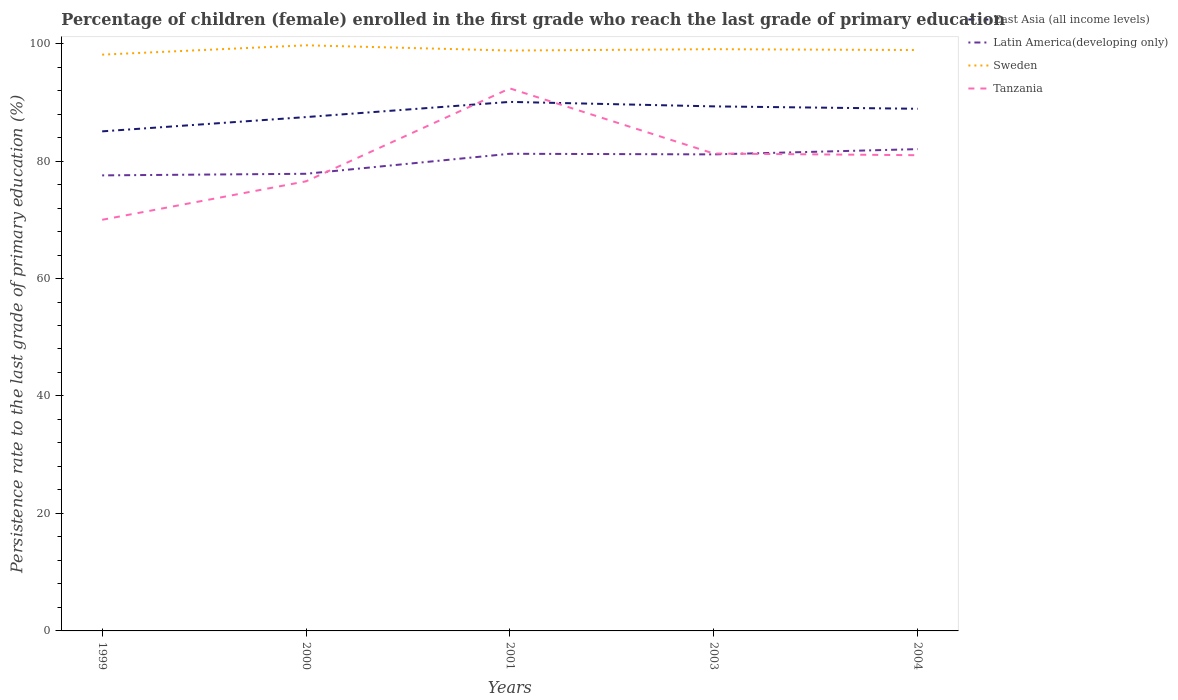How many different coloured lines are there?
Keep it short and to the point. 4. Does the line corresponding to Latin America(developing only) intersect with the line corresponding to East Asia (all income levels)?
Keep it short and to the point. No. Is the number of lines equal to the number of legend labels?
Your answer should be compact. Yes. Across all years, what is the maximum persistence rate of children in Tanzania?
Ensure brevity in your answer.  70. What is the total persistence rate of children in Sweden in the graph?
Your answer should be very brief. -0.23. What is the difference between the highest and the second highest persistence rate of children in East Asia (all income levels)?
Your answer should be compact. 5.02. What is the difference between the highest and the lowest persistence rate of children in East Asia (all income levels)?
Make the answer very short. 3. Does the graph contain any zero values?
Ensure brevity in your answer.  No. How many legend labels are there?
Give a very brief answer. 4. What is the title of the graph?
Your answer should be very brief. Percentage of children (female) enrolled in the first grade who reach the last grade of primary education. What is the label or title of the Y-axis?
Provide a short and direct response. Persistence rate to the last grade of primary education (%). What is the Persistence rate to the last grade of primary education (%) in East Asia (all income levels) in 1999?
Ensure brevity in your answer.  85.05. What is the Persistence rate to the last grade of primary education (%) in Latin America(developing only) in 1999?
Offer a very short reply. 77.56. What is the Persistence rate to the last grade of primary education (%) of Sweden in 1999?
Your answer should be compact. 98.12. What is the Persistence rate to the last grade of primary education (%) of Tanzania in 1999?
Provide a short and direct response. 70. What is the Persistence rate to the last grade of primary education (%) of East Asia (all income levels) in 2000?
Offer a very short reply. 87.48. What is the Persistence rate to the last grade of primary education (%) of Latin America(developing only) in 2000?
Provide a short and direct response. 77.83. What is the Persistence rate to the last grade of primary education (%) of Sweden in 2000?
Give a very brief answer. 99.7. What is the Persistence rate to the last grade of primary education (%) in Tanzania in 2000?
Give a very brief answer. 76.55. What is the Persistence rate to the last grade of primary education (%) in East Asia (all income levels) in 2001?
Make the answer very short. 90.07. What is the Persistence rate to the last grade of primary education (%) in Latin America(developing only) in 2001?
Keep it short and to the point. 81.24. What is the Persistence rate to the last grade of primary education (%) in Sweden in 2001?
Ensure brevity in your answer.  98.81. What is the Persistence rate to the last grade of primary education (%) of Tanzania in 2001?
Your answer should be compact. 92.36. What is the Persistence rate to the last grade of primary education (%) in East Asia (all income levels) in 2003?
Offer a very short reply. 89.31. What is the Persistence rate to the last grade of primary education (%) in Latin America(developing only) in 2003?
Offer a very short reply. 81.13. What is the Persistence rate to the last grade of primary education (%) of Sweden in 2003?
Make the answer very short. 99.04. What is the Persistence rate to the last grade of primary education (%) in Tanzania in 2003?
Ensure brevity in your answer.  81.28. What is the Persistence rate to the last grade of primary education (%) in East Asia (all income levels) in 2004?
Make the answer very short. 88.9. What is the Persistence rate to the last grade of primary education (%) in Latin America(developing only) in 2004?
Offer a very short reply. 82.03. What is the Persistence rate to the last grade of primary education (%) of Sweden in 2004?
Provide a succinct answer. 98.9. What is the Persistence rate to the last grade of primary education (%) in Tanzania in 2004?
Make the answer very short. 80.99. Across all years, what is the maximum Persistence rate to the last grade of primary education (%) in East Asia (all income levels)?
Provide a short and direct response. 90.07. Across all years, what is the maximum Persistence rate to the last grade of primary education (%) in Latin America(developing only)?
Give a very brief answer. 82.03. Across all years, what is the maximum Persistence rate to the last grade of primary education (%) in Sweden?
Provide a succinct answer. 99.7. Across all years, what is the maximum Persistence rate to the last grade of primary education (%) in Tanzania?
Your answer should be compact. 92.36. Across all years, what is the minimum Persistence rate to the last grade of primary education (%) of East Asia (all income levels)?
Your answer should be compact. 85.05. Across all years, what is the minimum Persistence rate to the last grade of primary education (%) of Latin America(developing only)?
Offer a terse response. 77.56. Across all years, what is the minimum Persistence rate to the last grade of primary education (%) in Sweden?
Offer a terse response. 98.12. Across all years, what is the minimum Persistence rate to the last grade of primary education (%) in Tanzania?
Offer a very short reply. 70. What is the total Persistence rate to the last grade of primary education (%) in East Asia (all income levels) in the graph?
Give a very brief answer. 440.81. What is the total Persistence rate to the last grade of primary education (%) in Latin America(developing only) in the graph?
Give a very brief answer. 399.79. What is the total Persistence rate to the last grade of primary education (%) of Sweden in the graph?
Keep it short and to the point. 494.57. What is the total Persistence rate to the last grade of primary education (%) in Tanzania in the graph?
Offer a very short reply. 401.18. What is the difference between the Persistence rate to the last grade of primary education (%) of East Asia (all income levels) in 1999 and that in 2000?
Keep it short and to the point. -2.43. What is the difference between the Persistence rate to the last grade of primary education (%) in Latin America(developing only) in 1999 and that in 2000?
Your answer should be very brief. -0.27. What is the difference between the Persistence rate to the last grade of primary education (%) in Sweden in 1999 and that in 2000?
Your answer should be compact. -1.59. What is the difference between the Persistence rate to the last grade of primary education (%) of Tanzania in 1999 and that in 2000?
Your answer should be compact. -6.55. What is the difference between the Persistence rate to the last grade of primary education (%) in East Asia (all income levels) in 1999 and that in 2001?
Ensure brevity in your answer.  -5.02. What is the difference between the Persistence rate to the last grade of primary education (%) in Latin America(developing only) in 1999 and that in 2001?
Your answer should be compact. -3.68. What is the difference between the Persistence rate to the last grade of primary education (%) in Sweden in 1999 and that in 2001?
Your answer should be compact. -0.7. What is the difference between the Persistence rate to the last grade of primary education (%) of Tanzania in 1999 and that in 2001?
Ensure brevity in your answer.  -22.37. What is the difference between the Persistence rate to the last grade of primary education (%) of East Asia (all income levels) in 1999 and that in 2003?
Your answer should be very brief. -4.25. What is the difference between the Persistence rate to the last grade of primary education (%) of Latin America(developing only) in 1999 and that in 2003?
Offer a terse response. -3.57. What is the difference between the Persistence rate to the last grade of primary education (%) in Sweden in 1999 and that in 2003?
Keep it short and to the point. -0.93. What is the difference between the Persistence rate to the last grade of primary education (%) in Tanzania in 1999 and that in 2003?
Provide a succinct answer. -11.28. What is the difference between the Persistence rate to the last grade of primary education (%) of East Asia (all income levels) in 1999 and that in 2004?
Make the answer very short. -3.85. What is the difference between the Persistence rate to the last grade of primary education (%) of Latin America(developing only) in 1999 and that in 2004?
Your response must be concise. -4.47. What is the difference between the Persistence rate to the last grade of primary education (%) in Sweden in 1999 and that in 2004?
Provide a short and direct response. -0.78. What is the difference between the Persistence rate to the last grade of primary education (%) of Tanzania in 1999 and that in 2004?
Make the answer very short. -10.99. What is the difference between the Persistence rate to the last grade of primary education (%) of East Asia (all income levels) in 2000 and that in 2001?
Your answer should be compact. -2.59. What is the difference between the Persistence rate to the last grade of primary education (%) of Latin America(developing only) in 2000 and that in 2001?
Offer a very short reply. -3.41. What is the difference between the Persistence rate to the last grade of primary education (%) in Sweden in 2000 and that in 2001?
Your answer should be very brief. 0.89. What is the difference between the Persistence rate to the last grade of primary education (%) of Tanzania in 2000 and that in 2001?
Provide a succinct answer. -15.82. What is the difference between the Persistence rate to the last grade of primary education (%) in East Asia (all income levels) in 2000 and that in 2003?
Make the answer very short. -1.82. What is the difference between the Persistence rate to the last grade of primary education (%) in Latin America(developing only) in 2000 and that in 2003?
Offer a terse response. -3.3. What is the difference between the Persistence rate to the last grade of primary education (%) of Sweden in 2000 and that in 2003?
Keep it short and to the point. 0.66. What is the difference between the Persistence rate to the last grade of primary education (%) in Tanzania in 2000 and that in 2003?
Your answer should be compact. -4.73. What is the difference between the Persistence rate to the last grade of primary education (%) of East Asia (all income levels) in 2000 and that in 2004?
Your answer should be compact. -1.41. What is the difference between the Persistence rate to the last grade of primary education (%) of Latin America(developing only) in 2000 and that in 2004?
Keep it short and to the point. -4.2. What is the difference between the Persistence rate to the last grade of primary education (%) in Sweden in 2000 and that in 2004?
Provide a succinct answer. 0.81. What is the difference between the Persistence rate to the last grade of primary education (%) in Tanzania in 2000 and that in 2004?
Offer a terse response. -4.45. What is the difference between the Persistence rate to the last grade of primary education (%) in East Asia (all income levels) in 2001 and that in 2003?
Offer a very short reply. 0.76. What is the difference between the Persistence rate to the last grade of primary education (%) in Latin America(developing only) in 2001 and that in 2003?
Offer a very short reply. 0.1. What is the difference between the Persistence rate to the last grade of primary education (%) in Sweden in 2001 and that in 2003?
Make the answer very short. -0.23. What is the difference between the Persistence rate to the last grade of primary education (%) in Tanzania in 2001 and that in 2003?
Offer a very short reply. 11.09. What is the difference between the Persistence rate to the last grade of primary education (%) of East Asia (all income levels) in 2001 and that in 2004?
Offer a terse response. 1.17. What is the difference between the Persistence rate to the last grade of primary education (%) of Latin America(developing only) in 2001 and that in 2004?
Your answer should be very brief. -0.79. What is the difference between the Persistence rate to the last grade of primary education (%) in Sweden in 2001 and that in 2004?
Give a very brief answer. -0.09. What is the difference between the Persistence rate to the last grade of primary education (%) in Tanzania in 2001 and that in 2004?
Offer a terse response. 11.37. What is the difference between the Persistence rate to the last grade of primary education (%) of East Asia (all income levels) in 2003 and that in 2004?
Your answer should be compact. 0.41. What is the difference between the Persistence rate to the last grade of primary education (%) in Latin America(developing only) in 2003 and that in 2004?
Provide a succinct answer. -0.89. What is the difference between the Persistence rate to the last grade of primary education (%) in Sweden in 2003 and that in 2004?
Provide a short and direct response. 0.14. What is the difference between the Persistence rate to the last grade of primary education (%) of Tanzania in 2003 and that in 2004?
Offer a very short reply. 0.28. What is the difference between the Persistence rate to the last grade of primary education (%) of East Asia (all income levels) in 1999 and the Persistence rate to the last grade of primary education (%) of Latin America(developing only) in 2000?
Your response must be concise. 7.22. What is the difference between the Persistence rate to the last grade of primary education (%) in East Asia (all income levels) in 1999 and the Persistence rate to the last grade of primary education (%) in Sweden in 2000?
Offer a very short reply. -14.65. What is the difference between the Persistence rate to the last grade of primary education (%) in East Asia (all income levels) in 1999 and the Persistence rate to the last grade of primary education (%) in Tanzania in 2000?
Keep it short and to the point. 8.51. What is the difference between the Persistence rate to the last grade of primary education (%) in Latin America(developing only) in 1999 and the Persistence rate to the last grade of primary education (%) in Sweden in 2000?
Your answer should be compact. -22.15. What is the difference between the Persistence rate to the last grade of primary education (%) of Sweden in 1999 and the Persistence rate to the last grade of primary education (%) of Tanzania in 2000?
Provide a short and direct response. 21.57. What is the difference between the Persistence rate to the last grade of primary education (%) in East Asia (all income levels) in 1999 and the Persistence rate to the last grade of primary education (%) in Latin America(developing only) in 2001?
Your answer should be very brief. 3.82. What is the difference between the Persistence rate to the last grade of primary education (%) in East Asia (all income levels) in 1999 and the Persistence rate to the last grade of primary education (%) in Sweden in 2001?
Keep it short and to the point. -13.76. What is the difference between the Persistence rate to the last grade of primary education (%) in East Asia (all income levels) in 1999 and the Persistence rate to the last grade of primary education (%) in Tanzania in 2001?
Your answer should be very brief. -7.31. What is the difference between the Persistence rate to the last grade of primary education (%) of Latin America(developing only) in 1999 and the Persistence rate to the last grade of primary education (%) of Sweden in 2001?
Ensure brevity in your answer.  -21.25. What is the difference between the Persistence rate to the last grade of primary education (%) of Latin America(developing only) in 1999 and the Persistence rate to the last grade of primary education (%) of Tanzania in 2001?
Offer a terse response. -14.81. What is the difference between the Persistence rate to the last grade of primary education (%) in Sweden in 1999 and the Persistence rate to the last grade of primary education (%) in Tanzania in 2001?
Provide a short and direct response. 5.75. What is the difference between the Persistence rate to the last grade of primary education (%) of East Asia (all income levels) in 1999 and the Persistence rate to the last grade of primary education (%) of Latin America(developing only) in 2003?
Your response must be concise. 3.92. What is the difference between the Persistence rate to the last grade of primary education (%) of East Asia (all income levels) in 1999 and the Persistence rate to the last grade of primary education (%) of Sweden in 2003?
Your response must be concise. -13.99. What is the difference between the Persistence rate to the last grade of primary education (%) of East Asia (all income levels) in 1999 and the Persistence rate to the last grade of primary education (%) of Tanzania in 2003?
Keep it short and to the point. 3.78. What is the difference between the Persistence rate to the last grade of primary education (%) of Latin America(developing only) in 1999 and the Persistence rate to the last grade of primary education (%) of Sweden in 2003?
Provide a succinct answer. -21.48. What is the difference between the Persistence rate to the last grade of primary education (%) in Latin America(developing only) in 1999 and the Persistence rate to the last grade of primary education (%) in Tanzania in 2003?
Make the answer very short. -3.72. What is the difference between the Persistence rate to the last grade of primary education (%) in Sweden in 1999 and the Persistence rate to the last grade of primary education (%) in Tanzania in 2003?
Your answer should be very brief. 16.84. What is the difference between the Persistence rate to the last grade of primary education (%) in East Asia (all income levels) in 1999 and the Persistence rate to the last grade of primary education (%) in Latin America(developing only) in 2004?
Your response must be concise. 3.03. What is the difference between the Persistence rate to the last grade of primary education (%) in East Asia (all income levels) in 1999 and the Persistence rate to the last grade of primary education (%) in Sweden in 2004?
Offer a terse response. -13.84. What is the difference between the Persistence rate to the last grade of primary education (%) of East Asia (all income levels) in 1999 and the Persistence rate to the last grade of primary education (%) of Tanzania in 2004?
Provide a succinct answer. 4.06. What is the difference between the Persistence rate to the last grade of primary education (%) of Latin America(developing only) in 1999 and the Persistence rate to the last grade of primary education (%) of Sweden in 2004?
Provide a short and direct response. -21.34. What is the difference between the Persistence rate to the last grade of primary education (%) in Latin America(developing only) in 1999 and the Persistence rate to the last grade of primary education (%) in Tanzania in 2004?
Provide a succinct answer. -3.43. What is the difference between the Persistence rate to the last grade of primary education (%) in Sweden in 1999 and the Persistence rate to the last grade of primary education (%) in Tanzania in 2004?
Ensure brevity in your answer.  17.12. What is the difference between the Persistence rate to the last grade of primary education (%) in East Asia (all income levels) in 2000 and the Persistence rate to the last grade of primary education (%) in Latin America(developing only) in 2001?
Your response must be concise. 6.25. What is the difference between the Persistence rate to the last grade of primary education (%) in East Asia (all income levels) in 2000 and the Persistence rate to the last grade of primary education (%) in Sweden in 2001?
Offer a very short reply. -11.33. What is the difference between the Persistence rate to the last grade of primary education (%) of East Asia (all income levels) in 2000 and the Persistence rate to the last grade of primary education (%) of Tanzania in 2001?
Provide a short and direct response. -4.88. What is the difference between the Persistence rate to the last grade of primary education (%) of Latin America(developing only) in 2000 and the Persistence rate to the last grade of primary education (%) of Sweden in 2001?
Give a very brief answer. -20.98. What is the difference between the Persistence rate to the last grade of primary education (%) in Latin America(developing only) in 2000 and the Persistence rate to the last grade of primary education (%) in Tanzania in 2001?
Provide a succinct answer. -14.53. What is the difference between the Persistence rate to the last grade of primary education (%) in Sweden in 2000 and the Persistence rate to the last grade of primary education (%) in Tanzania in 2001?
Your answer should be compact. 7.34. What is the difference between the Persistence rate to the last grade of primary education (%) of East Asia (all income levels) in 2000 and the Persistence rate to the last grade of primary education (%) of Latin America(developing only) in 2003?
Your response must be concise. 6.35. What is the difference between the Persistence rate to the last grade of primary education (%) of East Asia (all income levels) in 2000 and the Persistence rate to the last grade of primary education (%) of Sweden in 2003?
Provide a short and direct response. -11.56. What is the difference between the Persistence rate to the last grade of primary education (%) of East Asia (all income levels) in 2000 and the Persistence rate to the last grade of primary education (%) of Tanzania in 2003?
Provide a succinct answer. 6.21. What is the difference between the Persistence rate to the last grade of primary education (%) in Latin America(developing only) in 2000 and the Persistence rate to the last grade of primary education (%) in Sweden in 2003?
Keep it short and to the point. -21.21. What is the difference between the Persistence rate to the last grade of primary education (%) in Latin America(developing only) in 2000 and the Persistence rate to the last grade of primary education (%) in Tanzania in 2003?
Your answer should be compact. -3.44. What is the difference between the Persistence rate to the last grade of primary education (%) of Sweden in 2000 and the Persistence rate to the last grade of primary education (%) of Tanzania in 2003?
Make the answer very short. 18.43. What is the difference between the Persistence rate to the last grade of primary education (%) of East Asia (all income levels) in 2000 and the Persistence rate to the last grade of primary education (%) of Latin America(developing only) in 2004?
Make the answer very short. 5.46. What is the difference between the Persistence rate to the last grade of primary education (%) in East Asia (all income levels) in 2000 and the Persistence rate to the last grade of primary education (%) in Sweden in 2004?
Make the answer very short. -11.41. What is the difference between the Persistence rate to the last grade of primary education (%) of East Asia (all income levels) in 2000 and the Persistence rate to the last grade of primary education (%) of Tanzania in 2004?
Give a very brief answer. 6.49. What is the difference between the Persistence rate to the last grade of primary education (%) in Latin America(developing only) in 2000 and the Persistence rate to the last grade of primary education (%) in Sweden in 2004?
Offer a very short reply. -21.07. What is the difference between the Persistence rate to the last grade of primary education (%) in Latin America(developing only) in 2000 and the Persistence rate to the last grade of primary education (%) in Tanzania in 2004?
Your answer should be compact. -3.16. What is the difference between the Persistence rate to the last grade of primary education (%) of Sweden in 2000 and the Persistence rate to the last grade of primary education (%) of Tanzania in 2004?
Your answer should be compact. 18.71. What is the difference between the Persistence rate to the last grade of primary education (%) in East Asia (all income levels) in 2001 and the Persistence rate to the last grade of primary education (%) in Latin America(developing only) in 2003?
Make the answer very short. 8.94. What is the difference between the Persistence rate to the last grade of primary education (%) of East Asia (all income levels) in 2001 and the Persistence rate to the last grade of primary education (%) of Sweden in 2003?
Provide a short and direct response. -8.97. What is the difference between the Persistence rate to the last grade of primary education (%) of East Asia (all income levels) in 2001 and the Persistence rate to the last grade of primary education (%) of Tanzania in 2003?
Keep it short and to the point. 8.79. What is the difference between the Persistence rate to the last grade of primary education (%) of Latin America(developing only) in 2001 and the Persistence rate to the last grade of primary education (%) of Sweden in 2003?
Provide a short and direct response. -17.8. What is the difference between the Persistence rate to the last grade of primary education (%) of Latin America(developing only) in 2001 and the Persistence rate to the last grade of primary education (%) of Tanzania in 2003?
Offer a terse response. -0.04. What is the difference between the Persistence rate to the last grade of primary education (%) of Sweden in 2001 and the Persistence rate to the last grade of primary education (%) of Tanzania in 2003?
Offer a terse response. 17.54. What is the difference between the Persistence rate to the last grade of primary education (%) of East Asia (all income levels) in 2001 and the Persistence rate to the last grade of primary education (%) of Latin America(developing only) in 2004?
Provide a short and direct response. 8.04. What is the difference between the Persistence rate to the last grade of primary education (%) in East Asia (all income levels) in 2001 and the Persistence rate to the last grade of primary education (%) in Sweden in 2004?
Provide a short and direct response. -8.83. What is the difference between the Persistence rate to the last grade of primary education (%) in East Asia (all income levels) in 2001 and the Persistence rate to the last grade of primary education (%) in Tanzania in 2004?
Your answer should be compact. 9.08. What is the difference between the Persistence rate to the last grade of primary education (%) of Latin America(developing only) in 2001 and the Persistence rate to the last grade of primary education (%) of Sweden in 2004?
Give a very brief answer. -17.66. What is the difference between the Persistence rate to the last grade of primary education (%) in Latin America(developing only) in 2001 and the Persistence rate to the last grade of primary education (%) in Tanzania in 2004?
Provide a succinct answer. 0.24. What is the difference between the Persistence rate to the last grade of primary education (%) of Sweden in 2001 and the Persistence rate to the last grade of primary education (%) of Tanzania in 2004?
Provide a succinct answer. 17.82. What is the difference between the Persistence rate to the last grade of primary education (%) of East Asia (all income levels) in 2003 and the Persistence rate to the last grade of primary education (%) of Latin America(developing only) in 2004?
Provide a short and direct response. 7.28. What is the difference between the Persistence rate to the last grade of primary education (%) of East Asia (all income levels) in 2003 and the Persistence rate to the last grade of primary education (%) of Sweden in 2004?
Give a very brief answer. -9.59. What is the difference between the Persistence rate to the last grade of primary education (%) of East Asia (all income levels) in 2003 and the Persistence rate to the last grade of primary education (%) of Tanzania in 2004?
Your answer should be very brief. 8.31. What is the difference between the Persistence rate to the last grade of primary education (%) in Latin America(developing only) in 2003 and the Persistence rate to the last grade of primary education (%) in Sweden in 2004?
Your response must be concise. -17.76. What is the difference between the Persistence rate to the last grade of primary education (%) of Latin America(developing only) in 2003 and the Persistence rate to the last grade of primary education (%) of Tanzania in 2004?
Your response must be concise. 0.14. What is the difference between the Persistence rate to the last grade of primary education (%) of Sweden in 2003 and the Persistence rate to the last grade of primary education (%) of Tanzania in 2004?
Offer a terse response. 18.05. What is the average Persistence rate to the last grade of primary education (%) in East Asia (all income levels) per year?
Offer a terse response. 88.16. What is the average Persistence rate to the last grade of primary education (%) in Latin America(developing only) per year?
Your response must be concise. 79.96. What is the average Persistence rate to the last grade of primary education (%) in Sweden per year?
Your response must be concise. 98.91. What is the average Persistence rate to the last grade of primary education (%) in Tanzania per year?
Offer a terse response. 80.24. In the year 1999, what is the difference between the Persistence rate to the last grade of primary education (%) in East Asia (all income levels) and Persistence rate to the last grade of primary education (%) in Latin America(developing only)?
Your response must be concise. 7.49. In the year 1999, what is the difference between the Persistence rate to the last grade of primary education (%) in East Asia (all income levels) and Persistence rate to the last grade of primary education (%) in Sweden?
Give a very brief answer. -13.06. In the year 1999, what is the difference between the Persistence rate to the last grade of primary education (%) of East Asia (all income levels) and Persistence rate to the last grade of primary education (%) of Tanzania?
Provide a short and direct response. 15.05. In the year 1999, what is the difference between the Persistence rate to the last grade of primary education (%) of Latin America(developing only) and Persistence rate to the last grade of primary education (%) of Sweden?
Provide a short and direct response. -20.56. In the year 1999, what is the difference between the Persistence rate to the last grade of primary education (%) in Latin America(developing only) and Persistence rate to the last grade of primary education (%) in Tanzania?
Your answer should be very brief. 7.56. In the year 1999, what is the difference between the Persistence rate to the last grade of primary education (%) in Sweden and Persistence rate to the last grade of primary education (%) in Tanzania?
Your answer should be very brief. 28.12. In the year 2000, what is the difference between the Persistence rate to the last grade of primary education (%) in East Asia (all income levels) and Persistence rate to the last grade of primary education (%) in Latin America(developing only)?
Make the answer very short. 9.65. In the year 2000, what is the difference between the Persistence rate to the last grade of primary education (%) in East Asia (all income levels) and Persistence rate to the last grade of primary education (%) in Sweden?
Your answer should be compact. -12.22. In the year 2000, what is the difference between the Persistence rate to the last grade of primary education (%) of East Asia (all income levels) and Persistence rate to the last grade of primary education (%) of Tanzania?
Ensure brevity in your answer.  10.94. In the year 2000, what is the difference between the Persistence rate to the last grade of primary education (%) in Latin America(developing only) and Persistence rate to the last grade of primary education (%) in Sweden?
Ensure brevity in your answer.  -21.87. In the year 2000, what is the difference between the Persistence rate to the last grade of primary education (%) in Latin America(developing only) and Persistence rate to the last grade of primary education (%) in Tanzania?
Give a very brief answer. 1.28. In the year 2000, what is the difference between the Persistence rate to the last grade of primary education (%) of Sweden and Persistence rate to the last grade of primary education (%) of Tanzania?
Provide a succinct answer. 23.16. In the year 2001, what is the difference between the Persistence rate to the last grade of primary education (%) in East Asia (all income levels) and Persistence rate to the last grade of primary education (%) in Latin America(developing only)?
Make the answer very short. 8.83. In the year 2001, what is the difference between the Persistence rate to the last grade of primary education (%) in East Asia (all income levels) and Persistence rate to the last grade of primary education (%) in Sweden?
Make the answer very short. -8.74. In the year 2001, what is the difference between the Persistence rate to the last grade of primary education (%) of East Asia (all income levels) and Persistence rate to the last grade of primary education (%) of Tanzania?
Your answer should be compact. -2.29. In the year 2001, what is the difference between the Persistence rate to the last grade of primary education (%) in Latin America(developing only) and Persistence rate to the last grade of primary education (%) in Sweden?
Make the answer very short. -17.57. In the year 2001, what is the difference between the Persistence rate to the last grade of primary education (%) in Latin America(developing only) and Persistence rate to the last grade of primary education (%) in Tanzania?
Provide a short and direct response. -11.13. In the year 2001, what is the difference between the Persistence rate to the last grade of primary education (%) in Sweden and Persistence rate to the last grade of primary education (%) in Tanzania?
Provide a short and direct response. 6.45. In the year 2003, what is the difference between the Persistence rate to the last grade of primary education (%) in East Asia (all income levels) and Persistence rate to the last grade of primary education (%) in Latin America(developing only)?
Your answer should be compact. 8.17. In the year 2003, what is the difference between the Persistence rate to the last grade of primary education (%) of East Asia (all income levels) and Persistence rate to the last grade of primary education (%) of Sweden?
Give a very brief answer. -9.73. In the year 2003, what is the difference between the Persistence rate to the last grade of primary education (%) in East Asia (all income levels) and Persistence rate to the last grade of primary education (%) in Tanzania?
Your answer should be very brief. 8.03. In the year 2003, what is the difference between the Persistence rate to the last grade of primary education (%) in Latin America(developing only) and Persistence rate to the last grade of primary education (%) in Sweden?
Your answer should be compact. -17.91. In the year 2003, what is the difference between the Persistence rate to the last grade of primary education (%) in Latin America(developing only) and Persistence rate to the last grade of primary education (%) in Tanzania?
Give a very brief answer. -0.14. In the year 2003, what is the difference between the Persistence rate to the last grade of primary education (%) in Sweden and Persistence rate to the last grade of primary education (%) in Tanzania?
Provide a succinct answer. 17.76. In the year 2004, what is the difference between the Persistence rate to the last grade of primary education (%) of East Asia (all income levels) and Persistence rate to the last grade of primary education (%) of Latin America(developing only)?
Offer a very short reply. 6.87. In the year 2004, what is the difference between the Persistence rate to the last grade of primary education (%) of East Asia (all income levels) and Persistence rate to the last grade of primary education (%) of Sweden?
Offer a very short reply. -10. In the year 2004, what is the difference between the Persistence rate to the last grade of primary education (%) in East Asia (all income levels) and Persistence rate to the last grade of primary education (%) in Tanzania?
Provide a succinct answer. 7.91. In the year 2004, what is the difference between the Persistence rate to the last grade of primary education (%) of Latin America(developing only) and Persistence rate to the last grade of primary education (%) of Sweden?
Make the answer very short. -16.87. In the year 2004, what is the difference between the Persistence rate to the last grade of primary education (%) in Latin America(developing only) and Persistence rate to the last grade of primary education (%) in Tanzania?
Make the answer very short. 1.03. In the year 2004, what is the difference between the Persistence rate to the last grade of primary education (%) in Sweden and Persistence rate to the last grade of primary education (%) in Tanzania?
Your response must be concise. 17.9. What is the ratio of the Persistence rate to the last grade of primary education (%) in East Asia (all income levels) in 1999 to that in 2000?
Ensure brevity in your answer.  0.97. What is the ratio of the Persistence rate to the last grade of primary education (%) in Latin America(developing only) in 1999 to that in 2000?
Provide a short and direct response. 1. What is the ratio of the Persistence rate to the last grade of primary education (%) of Sweden in 1999 to that in 2000?
Your response must be concise. 0.98. What is the ratio of the Persistence rate to the last grade of primary education (%) in Tanzania in 1999 to that in 2000?
Provide a short and direct response. 0.91. What is the ratio of the Persistence rate to the last grade of primary education (%) of East Asia (all income levels) in 1999 to that in 2001?
Ensure brevity in your answer.  0.94. What is the ratio of the Persistence rate to the last grade of primary education (%) in Latin America(developing only) in 1999 to that in 2001?
Your response must be concise. 0.95. What is the ratio of the Persistence rate to the last grade of primary education (%) of Sweden in 1999 to that in 2001?
Provide a short and direct response. 0.99. What is the ratio of the Persistence rate to the last grade of primary education (%) in Tanzania in 1999 to that in 2001?
Give a very brief answer. 0.76. What is the ratio of the Persistence rate to the last grade of primary education (%) in Latin America(developing only) in 1999 to that in 2003?
Keep it short and to the point. 0.96. What is the ratio of the Persistence rate to the last grade of primary education (%) of Tanzania in 1999 to that in 2003?
Your response must be concise. 0.86. What is the ratio of the Persistence rate to the last grade of primary education (%) in East Asia (all income levels) in 1999 to that in 2004?
Your answer should be compact. 0.96. What is the ratio of the Persistence rate to the last grade of primary education (%) in Latin America(developing only) in 1999 to that in 2004?
Your answer should be compact. 0.95. What is the ratio of the Persistence rate to the last grade of primary education (%) in Sweden in 1999 to that in 2004?
Provide a succinct answer. 0.99. What is the ratio of the Persistence rate to the last grade of primary education (%) in Tanzania in 1999 to that in 2004?
Keep it short and to the point. 0.86. What is the ratio of the Persistence rate to the last grade of primary education (%) in East Asia (all income levels) in 2000 to that in 2001?
Make the answer very short. 0.97. What is the ratio of the Persistence rate to the last grade of primary education (%) in Latin America(developing only) in 2000 to that in 2001?
Give a very brief answer. 0.96. What is the ratio of the Persistence rate to the last grade of primary education (%) of Tanzania in 2000 to that in 2001?
Provide a short and direct response. 0.83. What is the ratio of the Persistence rate to the last grade of primary education (%) in East Asia (all income levels) in 2000 to that in 2003?
Offer a terse response. 0.98. What is the ratio of the Persistence rate to the last grade of primary education (%) of Latin America(developing only) in 2000 to that in 2003?
Your response must be concise. 0.96. What is the ratio of the Persistence rate to the last grade of primary education (%) of Sweden in 2000 to that in 2003?
Your answer should be very brief. 1.01. What is the ratio of the Persistence rate to the last grade of primary education (%) in Tanzania in 2000 to that in 2003?
Offer a terse response. 0.94. What is the ratio of the Persistence rate to the last grade of primary education (%) of East Asia (all income levels) in 2000 to that in 2004?
Keep it short and to the point. 0.98. What is the ratio of the Persistence rate to the last grade of primary education (%) in Latin America(developing only) in 2000 to that in 2004?
Give a very brief answer. 0.95. What is the ratio of the Persistence rate to the last grade of primary education (%) of Sweden in 2000 to that in 2004?
Your answer should be very brief. 1.01. What is the ratio of the Persistence rate to the last grade of primary education (%) in Tanzania in 2000 to that in 2004?
Offer a very short reply. 0.95. What is the ratio of the Persistence rate to the last grade of primary education (%) of East Asia (all income levels) in 2001 to that in 2003?
Keep it short and to the point. 1.01. What is the ratio of the Persistence rate to the last grade of primary education (%) of Sweden in 2001 to that in 2003?
Offer a terse response. 1. What is the ratio of the Persistence rate to the last grade of primary education (%) of Tanzania in 2001 to that in 2003?
Your answer should be very brief. 1.14. What is the ratio of the Persistence rate to the last grade of primary education (%) in East Asia (all income levels) in 2001 to that in 2004?
Give a very brief answer. 1.01. What is the ratio of the Persistence rate to the last grade of primary education (%) of Latin America(developing only) in 2001 to that in 2004?
Keep it short and to the point. 0.99. What is the ratio of the Persistence rate to the last grade of primary education (%) in Sweden in 2001 to that in 2004?
Provide a succinct answer. 1. What is the ratio of the Persistence rate to the last grade of primary education (%) in Tanzania in 2001 to that in 2004?
Your response must be concise. 1.14. What is the difference between the highest and the second highest Persistence rate to the last grade of primary education (%) of East Asia (all income levels)?
Provide a short and direct response. 0.76. What is the difference between the highest and the second highest Persistence rate to the last grade of primary education (%) in Latin America(developing only)?
Ensure brevity in your answer.  0.79. What is the difference between the highest and the second highest Persistence rate to the last grade of primary education (%) in Sweden?
Provide a short and direct response. 0.66. What is the difference between the highest and the second highest Persistence rate to the last grade of primary education (%) in Tanzania?
Offer a terse response. 11.09. What is the difference between the highest and the lowest Persistence rate to the last grade of primary education (%) in East Asia (all income levels)?
Offer a very short reply. 5.02. What is the difference between the highest and the lowest Persistence rate to the last grade of primary education (%) in Latin America(developing only)?
Your answer should be compact. 4.47. What is the difference between the highest and the lowest Persistence rate to the last grade of primary education (%) in Sweden?
Make the answer very short. 1.59. What is the difference between the highest and the lowest Persistence rate to the last grade of primary education (%) of Tanzania?
Offer a terse response. 22.37. 